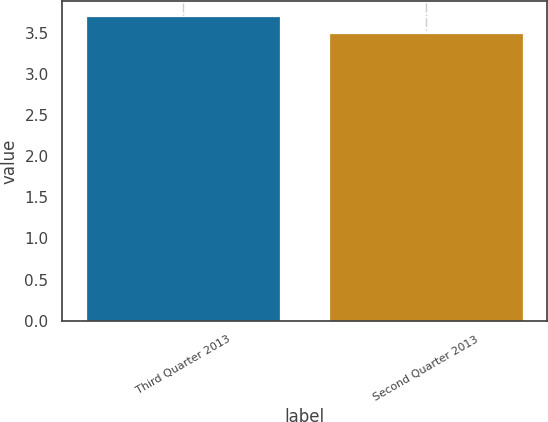Convert chart to OTSL. <chart><loc_0><loc_0><loc_500><loc_500><bar_chart><fcel>Third Quarter 2013<fcel>Second Quarter 2013<nl><fcel>3.7<fcel>3.5<nl></chart> 